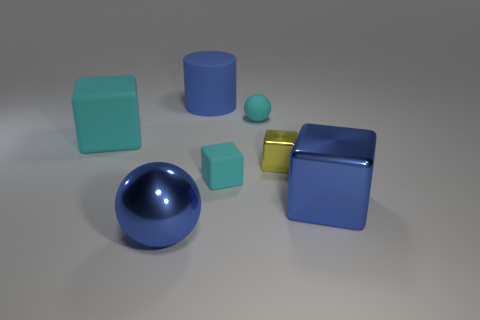Does the small matte object behind the yellow block have the same color as the big rubber cube?
Your answer should be very brief. Yes. Is the big blue thing that is in front of the big metallic block made of the same material as the blue cylinder?
Your answer should be very brief. No. There is a cyan object that is both right of the blue metallic sphere and in front of the cyan matte ball; what material is it made of?
Your answer should be compact. Rubber. What is the shape of the big matte thing that is the same color as the matte sphere?
Provide a succinct answer. Cube. There is a big rubber object that is on the right side of the big shiny sphere; what is its color?
Offer a very short reply. Blue. What is the size of the sphere that is the same material as the cylinder?
Make the answer very short. Small. Is the size of the metal sphere the same as the cube to the left of the big blue metal ball?
Your answer should be very brief. Yes. There is a blue object that is behind the small cyan ball; what is its material?
Your response must be concise. Rubber. There is a rubber block left of the large blue sphere; what number of cyan matte balls are behind it?
Make the answer very short. 1. Are there any big brown metallic objects that have the same shape as the tiny metallic object?
Make the answer very short. No. 